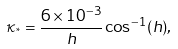Convert formula to latex. <formula><loc_0><loc_0><loc_500><loc_500>\kappa _ { ^ { * } } = \frac { 6 \times 1 0 ^ { - 3 } } { h } \cos ^ { - 1 } ( h ) ,</formula> 